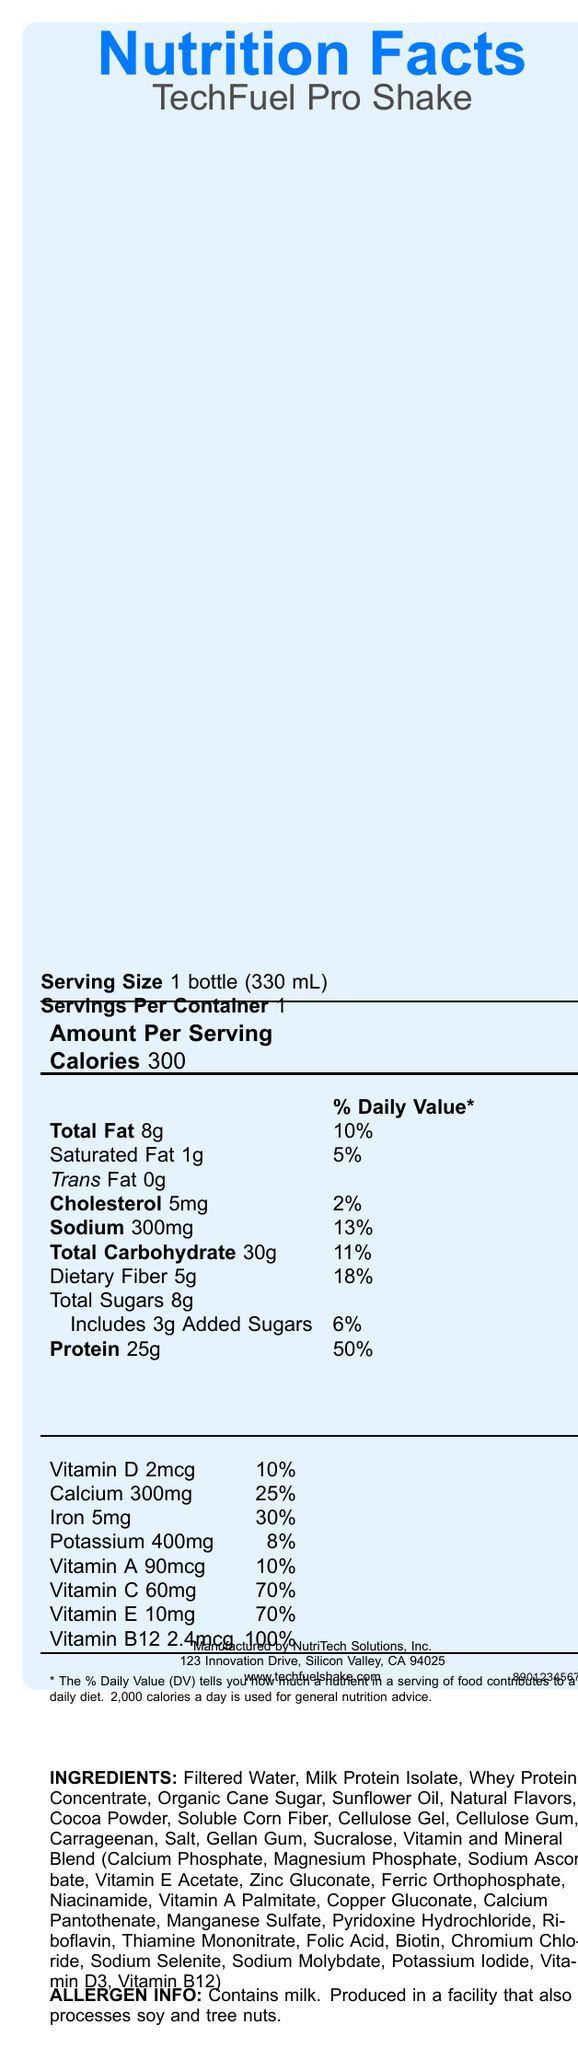what is the product name? The product name is stated at the beginning of the Nutrition Facts Label.
Answer: TechFuel Pro Shake how many calories are in one serving? Under the "Amount Per Serving" section, it lists "Calories 300".
Answer: 300 what is the serving size? The "Serving Size" is listed as 1 bottle (330 mL).
Answer: 1 bottle (330 mL) what is the total fat content per serving? The "Total Fat" content is provided in the table: 8g.
Answer: 8g how much dietary fiber does the shake contain? Under the "Total Carbohydrate" section, it lists "Dietary Fiber 5g".
Answer: 5g what is the amount of protein per serving? The amount of protein is listed as "25g" in the table.
Answer: 25g what percentage of the daily value of calcium does the shake provide? A. 10% B. 25% C. 50% D. 70% According to the vitamins and minerals section, calcium is 25% of the daily value.
Answer: B. 25% which vitamin has the highest daily value percentage? A. Vitamin A B. Vitamin C C. Vitamin B12 D. Vitamin D Vitamin B12 provides 100% of the daily value, which is the highest listed in the document.
Answer: C. Vitamin B12 does the shake contain any cholesterol? Yes/No The shake contains 5mg of cholesterol as listed in the document.
Answer: Yes describe the allergen information provided in the nutrition label. The allergen information states that the product contains milk and is produced in a facility that also processes soy and tree nuts.
Answer: Contains milk. Produced in a facility that also processes soy and tree nuts. where is the manufacturer located? The manufacturer's address is provided at the bottom of the document.
Answer: 123 Innovation Drive, Silicon Valley, CA 94025 can you find the expiration date on the label? The provided document does not include any information about the expiration date.
Answer: Not enough information do you need to refrigerate the shake? The storage instructions specify to keep the shake refrigerated.
Answer: Yes what is the barcode of the product? The barcode is listed at the end of the document.
Answer: 890123456789 how many added sugars are included in each serving of the shake? The label lists that there are 3g of added sugars included in the total sugars.
Answer: 3g does the shake provide more protein or carbohydrates? The shake provides 25g of protein compared to 30g of total carbohydrates, but considering daily value percentages, protein provides 50% vs carbohydrates' 11% daily value.
Answer: Protein 